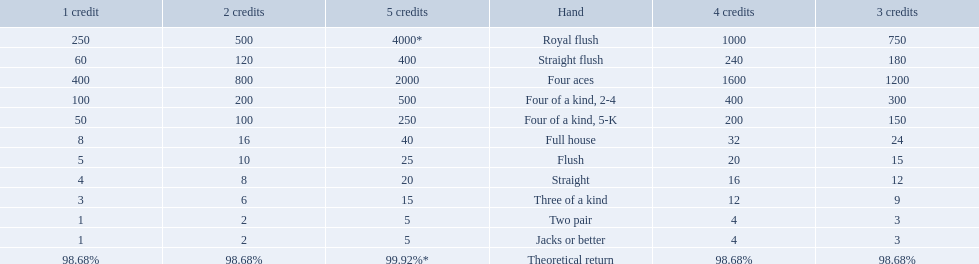Which hand is the third best hand in the card game super aces? Four aces. Which hand is the second best hand? Straight flush. Which hand had is the best hand? Royal flush. What is the values in the 5 credits area? 4000*, 400, 2000, 500, 250, 40, 25, 20, 15, 5, 5. Which of these is for a four of a kind? 500, 250. What is the higher value? 500. What hand is this for Four of a kind, 2-4. What are each of the hands? Royal flush, Straight flush, Four aces, Four of a kind, 2-4, Four of a kind, 5-K, Full house, Flush, Straight, Three of a kind, Two pair, Jacks or better, Theoretical return. Which hand ranks higher between straights and flushes? Flush. 